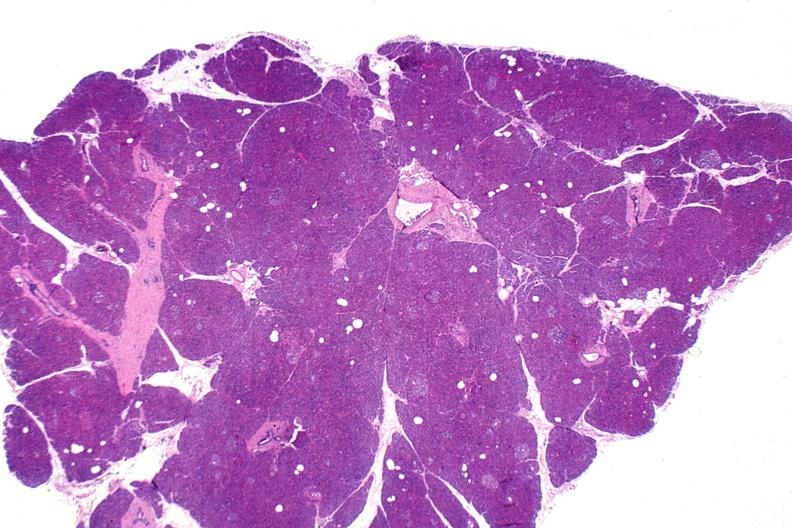does this image show normal pancreas?
Answer the question using a single word or phrase. Yes 